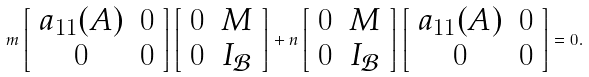<formula> <loc_0><loc_0><loc_500><loc_500>m \left [ \begin{array} { c c } a _ { 1 1 } ( A ) & 0 \\ 0 & 0 \\ \end{array} \right ] \left [ \begin{array} { c c } 0 & M \\ 0 & I _ { \mathcal { B } } \\ \end{array} \right ] + n \left [ \begin{array} { c c } 0 & M \\ 0 & I _ { \mathcal { B } } \\ \end{array} \right ] \left [ \begin{array} { c c } a _ { 1 1 } ( A ) & 0 \\ 0 & 0 \\ \end{array} \right ] = 0 .</formula> 